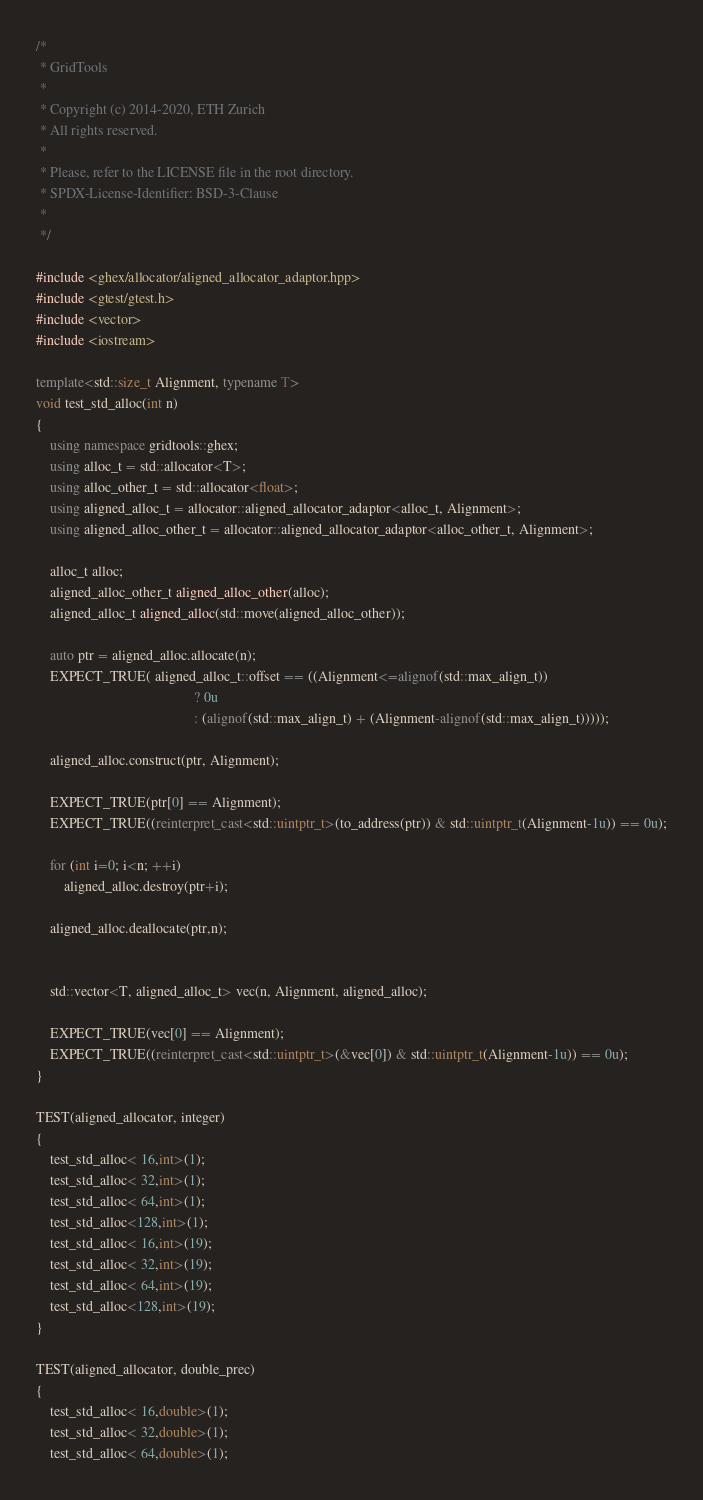<code> <loc_0><loc_0><loc_500><loc_500><_C++_>/* 
 * GridTools
 * 
 * Copyright (c) 2014-2020, ETH Zurich
 * All rights reserved.
 * 
 * Please, refer to the LICENSE file in the root directory.
 * SPDX-License-Identifier: BSD-3-Clause
 * 
 */

#include <ghex/allocator/aligned_allocator_adaptor.hpp>
#include <gtest/gtest.h>
#include <vector>
#include <iostream>

template<std::size_t Alignment, typename T>
void test_std_alloc(int n)
{
    using namespace gridtools::ghex;
    using alloc_t = std::allocator<T>;
    using alloc_other_t = std::allocator<float>;
    using aligned_alloc_t = allocator::aligned_allocator_adaptor<alloc_t, Alignment>;
    using aligned_alloc_other_t = allocator::aligned_allocator_adaptor<alloc_other_t, Alignment>;

    alloc_t alloc;
    aligned_alloc_other_t aligned_alloc_other(alloc);
    aligned_alloc_t aligned_alloc(std::move(aligned_alloc_other));
    
    auto ptr = aligned_alloc.allocate(n);
    EXPECT_TRUE( aligned_alloc_t::offset == ((Alignment<=alignof(std::max_align_t))
                                             ? 0u 
                                             : (alignof(std::max_align_t) + (Alignment-alignof(std::max_align_t)))));
    
    aligned_alloc.construct(ptr, Alignment);
    
    EXPECT_TRUE(ptr[0] == Alignment);
    EXPECT_TRUE((reinterpret_cast<std::uintptr_t>(to_address(ptr)) & std::uintptr_t(Alignment-1u)) == 0u);
    
    for (int i=0; i<n; ++i)
        aligned_alloc.destroy(ptr+i);

    aligned_alloc.deallocate(ptr,n);


    std::vector<T, aligned_alloc_t> vec(n, Alignment, aligned_alloc);

    EXPECT_TRUE(vec[0] == Alignment);
    EXPECT_TRUE((reinterpret_cast<std::uintptr_t>(&vec[0]) & std::uintptr_t(Alignment-1u)) == 0u);
}

TEST(aligned_allocator, integer)
{
    test_std_alloc< 16,int>(1);
    test_std_alloc< 32,int>(1);
    test_std_alloc< 64,int>(1);
    test_std_alloc<128,int>(1);
    test_std_alloc< 16,int>(19);
    test_std_alloc< 32,int>(19);
    test_std_alloc< 64,int>(19);
    test_std_alloc<128,int>(19);
}

TEST(aligned_allocator, double_prec)
{
    test_std_alloc< 16,double>(1);
    test_std_alloc< 32,double>(1);
    test_std_alloc< 64,double>(1);</code> 